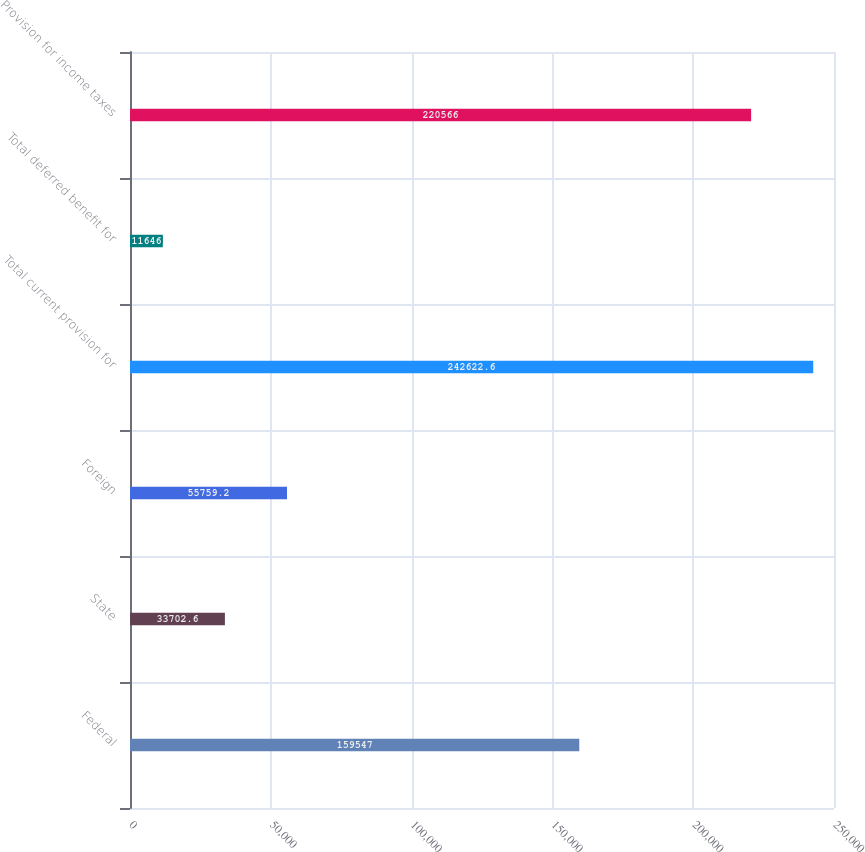Convert chart. <chart><loc_0><loc_0><loc_500><loc_500><bar_chart><fcel>Federal<fcel>State<fcel>Foreign<fcel>Total current provision for<fcel>Total deferred benefit for<fcel>Provision for income taxes<nl><fcel>159547<fcel>33702.6<fcel>55759.2<fcel>242623<fcel>11646<fcel>220566<nl></chart> 